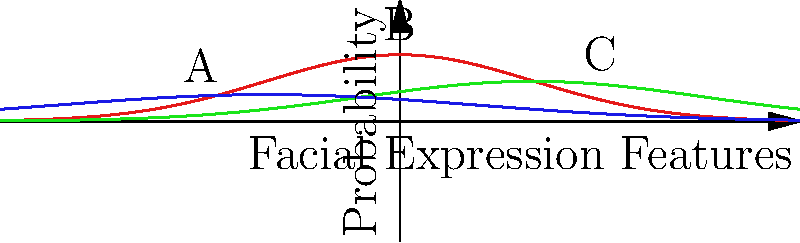Based on the graph showing probability distributions of facial expression features for different stress levels, which point (A, B, or C) most likely represents a high-stress facial expression? To determine which point represents a high-stress facial expression, we need to analyze the graph:

1. The graph shows three probability distributions corresponding to different stress levels:
   - Red curve: High Stress
   - Green curve: Moderate Stress
   - Blue curve: Low Stress

2. The x-axis represents facial expression features, while the y-axis represents probability.

3. Point A is located on the blue curve (Low Stress) at approximately (-1.5, 0.15).
4. Point B is located at the peak of the red curve (High Stress) at approximately (0, 0.5).
5. Point C is located on the green curve (Moderate Stress) at approximately (1.5, 0.2).

6. The point with the highest probability on the High Stress curve (red) is most likely to represent a high-stress facial expression.

7. Point B is at the peak of the red curve, indicating the highest probability for high-stress facial expression features.

Therefore, point B most likely represents a high-stress facial expression.
Answer: B 